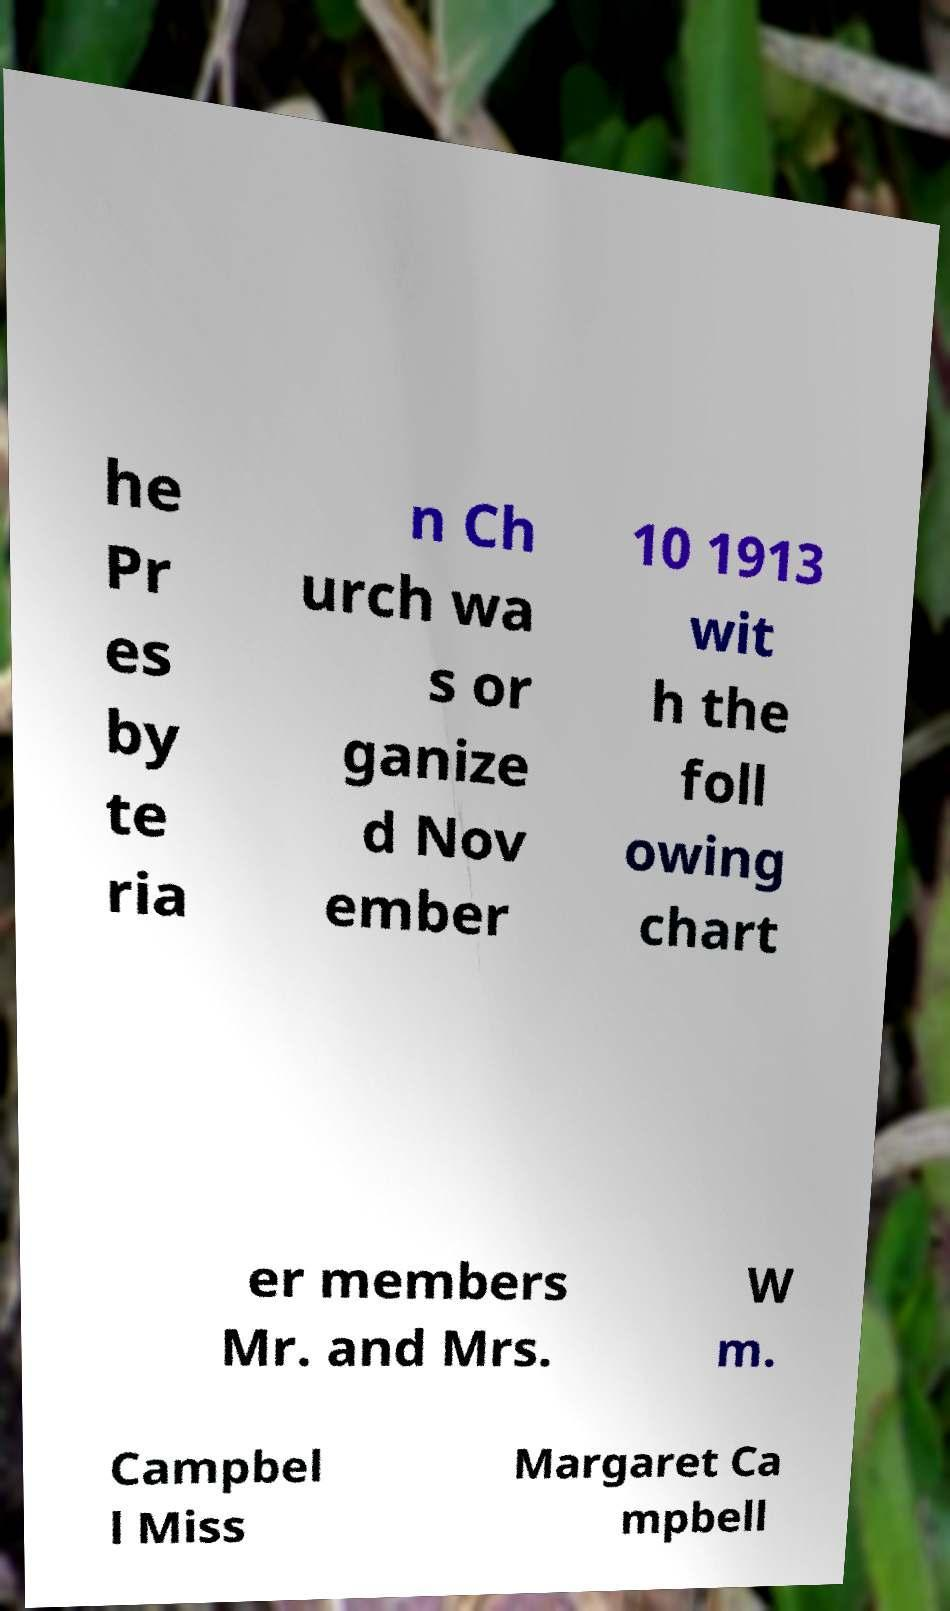Can you read and provide the text displayed in the image?This photo seems to have some interesting text. Can you extract and type it out for me? he Pr es by te ria n Ch urch wa s or ganize d Nov ember 10 1913 wit h the foll owing chart er members Mr. and Mrs. W m. Campbel l Miss Margaret Ca mpbell 